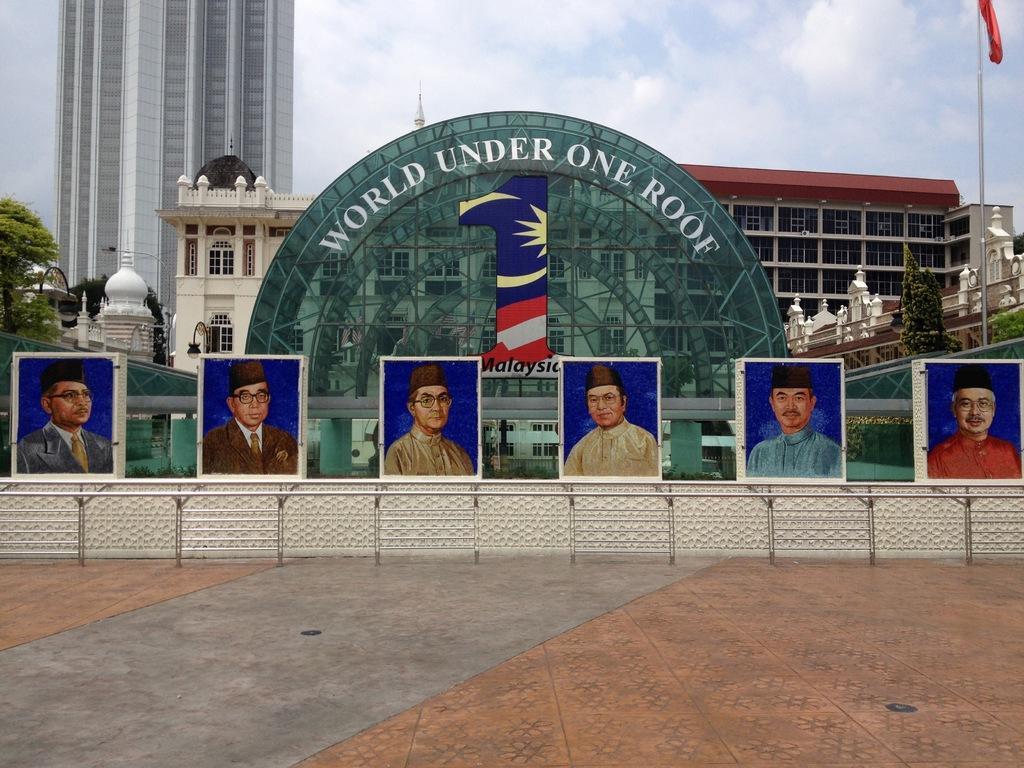Can you describe this image briefly? In the front of the image we can see ground. Above the road there are pictures of people. In the background there is a board, arches, buildings, trees, light poles, flag, cloudy sky and things. Something is written on the arch.   